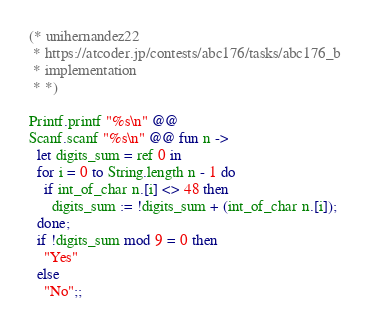<code> <loc_0><loc_0><loc_500><loc_500><_OCaml_>(* unihernandez22
 * https://atcoder.jp/contests/abc176/tasks/abc176_b
 * implementation
 * *)

Printf.printf "%s\n" @@
Scanf.scanf "%s\n" @@ fun n ->
  let digits_sum = ref 0 in
  for i = 0 to String.length n - 1 do
    if int_of_char n.[i] <> 48 then
      digits_sum := !digits_sum + (int_of_char n.[i]);
  done;
  if !digits_sum mod 9 = 0 then
    "Yes"
  else
    "No";;
</code> 